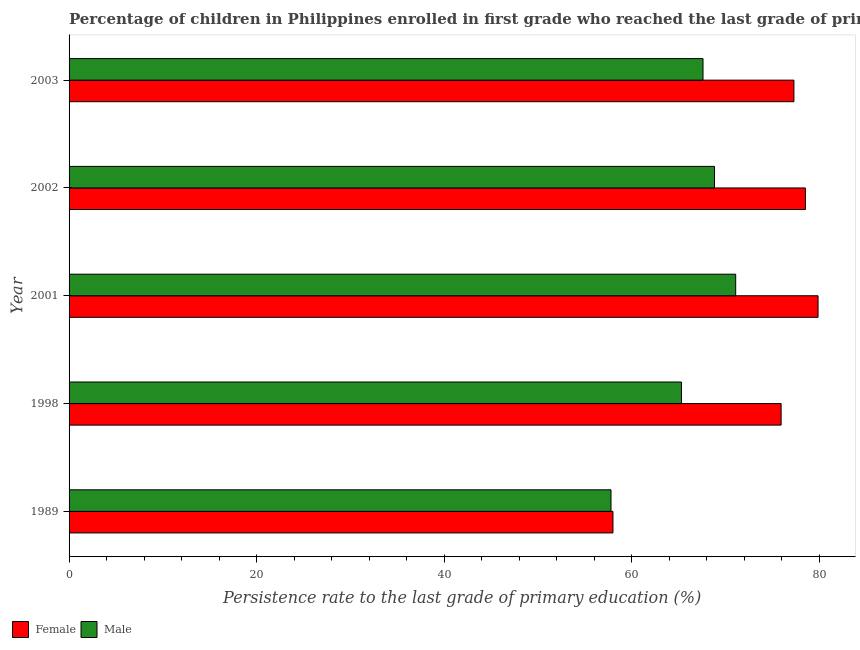How many groups of bars are there?
Your answer should be very brief. 5. Are the number of bars per tick equal to the number of legend labels?
Offer a very short reply. Yes. How many bars are there on the 2nd tick from the top?
Provide a succinct answer. 2. How many bars are there on the 1st tick from the bottom?
Offer a very short reply. 2. What is the label of the 5th group of bars from the top?
Your answer should be compact. 1989. What is the persistence rate of male students in 2001?
Offer a terse response. 71.07. Across all years, what is the maximum persistence rate of female students?
Your answer should be very brief. 79.85. Across all years, what is the minimum persistence rate of male students?
Your answer should be very brief. 57.78. In which year was the persistence rate of female students maximum?
Keep it short and to the point. 2001. What is the total persistence rate of female students in the graph?
Provide a short and direct response. 369.52. What is the difference between the persistence rate of female students in 1998 and that in 2003?
Keep it short and to the point. -1.36. What is the difference between the persistence rate of male students in 1989 and the persistence rate of female students in 2001?
Offer a terse response. -22.07. What is the average persistence rate of female students per year?
Offer a terse response. 73.9. In the year 1989, what is the difference between the persistence rate of male students and persistence rate of female students?
Provide a short and direct response. -0.21. What is the ratio of the persistence rate of male students in 1989 to that in 2001?
Give a very brief answer. 0.81. Is the difference between the persistence rate of male students in 1998 and 2002 greater than the difference between the persistence rate of female students in 1998 and 2002?
Keep it short and to the point. No. What is the difference between the highest and the second highest persistence rate of female students?
Ensure brevity in your answer.  1.35. What is the difference between the highest and the lowest persistence rate of female students?
Your answer should be compact. 21.86. In how many years, is the persistence rate of female students greater than the average persistence rate of female students taken over all years?
Your response must be concise. 4. What does the 2nd bar from the bottom in 2003 represents?
Keep it short and to the point. Male. Are the values on the major ticks of X-axis written in scientific E-notation?
Your response must be concise. No. Does the graph contain any zero values?
Provide a short and direct response. No. How are the legend labels stacked?
Ensure brevity in your answer.  Horizontal. What is the title of the graph?
Give a very brief answer. Percentage of children in Philippines enrolled in first grade who reached the last grade of primary education. Does "By country of asylum" appear as one of the legend labels in the graph?
Give a very brief answer. No. What is the label or title of the X-axis?
Offer a very short reply. Persistence rate to the last grade of primary education (%). What is the Persistence rate to the last grade of primary education (%) in Female in 1989?
Offer a very short reply. 57.98. What is the Persistence rate to the last grade of primary education (%) in Male in 1989?
Give a very brief answer. 57.78. What is the Persistence rate to the last grade of primary education (%) in Female in 1998?
Provide a succinct answer. 75.91. What is the Persistence rate to the last grade of primary education (%) in Male in 1998?
Provide a short and direct response. 65.29. What is the Persistence rate to the last grade of primary education (%) of Female in 2001?
Your answer should be compact. 79.85. What is the Persistence rate to the last grade of primary education (%) in Male in 2001?
Ensure brevity in your answer.  71.07. What is the Persistence rate to the last grade of primary education (%) of Female in 2002?
Keep it short and to the point. 78.5. What is the Persistence rate to the last grade of primary education (%) of Male in 2002?
Give a very brief answer. 68.81. What is the Persistence rate to the last grade of primary education (%) of Female in 2003?
Give a very brief answer. 77.28. What is the Persistence rate to the last grade of primary education (%) in Male in 2003?
Your answer should be very brief. 67.58. Across all years, what is the maximum Persistence rate to the last grade of primary education (%) of Female?
Your response must be concise. 79.85. Across all years, what is the maximum Persistence rate to the last grade of primary education (%) of Male?
Make the answer very short. 71.07. Across all years, what is the minimum Persistence rate to the last grade of primary education (%) in Female?
Your answer should be compact. 57.98. Across all years, what is the minimum Persistence rate to the last grade of primary education (%) of Male?
Provide a short and direct response. 57.78. What is the total Persistence rate to the last grade of primary education (%) of Female in the graph?
Your answer should be compact. 369.52. What is the total Persistence rate to the last grade of primary education (%) of Male in the graph?
Ensure brevity in your answer.  330.52. What is the difference between the Persistence rate to the last grade of primary education (%) in Female in 1989 and that in 1998?
Your answer should be very brief. -17.93. What is the difference between the Persistence rate to the last grade of primary education (%) in Male in 1989 and that in 1998?
Give a very brief answer. -7.51. What is the difference between the Persistence rate to the last grade of primary education (%) of Female in 1989 and that in 2001?
Keep it short and to the point. -21.86. What is the difference between the Persistence rate to the last grade of primary education (%) in Male in 1989 and that in 2001?
Offer a very short reply. -13.29. What is the difference between the Persistence rate to the last grade of primary education (%) of Female in 1989 and that in 2002?
Your answer should be very brief. -20.52. What is the difference between the Persistence rate to the last grade of primary education (%) in Male in 1989 and that in 2002?
Provide a short and direct response. -11.03. What is the difference between the Persistence rate to the last grade of primary education (%) in Female in 1989 and that in 2003?
Give a very brief answer. -19.29. What is the difference between the Persistence rate to the last grade of primary education (%) of Male in 1989 and that in 2003?
Make the answer very short. -9.81. What is the difference between the Persistence rate to the last grade of primary education (%) of Female in 1998 and that in 2001?
Your answer should be very brief. -3.94. What is the difference between the Persistence rate to the last grade of primary education (%) of Male in 1998 and that in 2001?
Your answer should be very brief. -5.78. What is the difference between the Persistence rate to the last grade of primary education (%) in Female in 1998 and that in 2002?
Your response must be concise. -2.59. What is the difference between the Persistence rate to the last grade of primary education (%) in Male in 1998 and that in 2002?
Your response must be concise. -3.52. What is the difference between the Persistence rate to the last grade of primary education (%) in Female in 1998 and that in 2003?
Your answer should be very brief. -1.37. What is the difference between the Persistence rate to the last grade of primary education (%) in Male in 1998 and that in 2003?
Your answer should be very brief. -2.3. What is the difference between the Persistence rate to the last grade of primary education (%) of Female in 2001 and that in 2002?
Your answer should be compact. 1.35. What is the difference between the Persistence rate to the last grade of primary education (%) in Male in 2001 and that in 2002?
Offer a very short reply. 2.26. What is the difference between the Persistence rate to the last grade of primary education (%) of Female in 2001 and that in 2003?
Keep it short and to the point. 2.57. What is the difference between the Persistence rate to the last grade of primary education (%) in Male in 2001 and that in 2003?
Make the answer very short. 3.48. What is the difference between the Persistence rate to the last grade of primary education (%) of Female in 2002 and that in 2003?
Ensure brevity in your answer.  1.23. What is the difference between the Persistence rate to the last grade of primary education (%) of Male in 2002 and that in 2003?
Make the answer very short. 1.22. What is the difference between the Persistence rate to the last grade of primary education (%) of Female in 1989 and the Persistence rate to the last grade of primary education (%) of Male in 1998?
Ensure brevity in your answer.  -7.3. What is the difference between the Persistence rate to the last grade of primary education (%) in Female in 1989 and the Persistence rate to the last grade of primary education (%) in Male in 2001?
Provide a short and direct response. -13.08. What is the difference between the Persistence rate to the last grade of primary education (%) in Female in 1989 and the Persistence rate to the last grade of primary education (%) in Male in 2002?
Ensure brevity in your answer.  -10.82. What is the difference between the Persistence rate to the last grade of primary education (%) of Female in 1989 and the Persistence rate to the last grade of primary education (%) of Male in 2003?
Ensure brevity in your answer.  -9.6. What is the difference between the Persistence rate to the last grade of primary education (%) of Female in 1998 and the Persistence rate to the last grade of primary education (%) of Male in 2001?
Offer a very short reply. 4.84. What is the difference between the Persistence rate to the last grade of primary education (%) of Female in 1998 and the Persistence rate to the last grade of primary education (%) of Male in 2002?
Keep it short and to the point. 7.1. What is the difference between the Persistence rate to the last grade of primary education (%) of Female in 1998 and the Persistence rate to the last grade of primary education (%) of Male in 2003?
Ensure brevity in your answer.  8.33. What is the difference between the Persistence rate to the last grade of primary education (%) in Female in 2001 and the Persistence rate to the last grade of primary education (%) in Male in 2002?
Offer a very short reply. 11.04. What is the difference between the Persistence rate to the last grade of primary education (%) in Female in 2001 and the Persistence rate to the last grade of primary education (%) in Male in 2003?
Keep it short and to the point. 12.26. What is the difference between the Persistence rate to the last grade of primary education (%) of Female in 2002 and the Persistence rate to the last grade of primary education (%) of Male in 2003?
Provide a succinct answer. 10.92. What is the average Persistence rate to the last grade of primary education (%) in Female per year?
Offer a very short reply. 73.9. What is the average Persistence rate to the last grade of primary education (%) in Male per year?
Offer a terse response. 66.1. In the year 1989, what is the difference between the Persistence rate to the last grade of primary education (%) of Female and Persistence rate to the last grade of primary education (%) of Male?
Your answer should be compact. 0.21. In the year 1998, what is the difference between the Persistence rate to the last grade of primary education (%) of Female and Persistence rate to the last grade of primary education (%) of Male?
Keep it short and to the point. 10.62. In the year 2001, what is the difference between the Persistence rate to the last grade of primary education (%) of Female and Persistence rate to the last grade of primary education (%) of Male?
Make the answer very short. 8.78. In the year 2002, what is the difference between the Persistence rate to the last grade of primary education (%) of Female and Persistence rate to the last grade of primary education (%) of Male?
Ensure brevity in your answer.  9.69. In the year 2003, what is the difference between the Persistence rate to the last grade of primary education (%) of Female and Persistence rate to the last grade of primary education (%) of Male?
Provide a succinct answer. 9.69. What is the ratio of the Persistence rate to the last grade of primary education (%) of Female in 1989 to that in 1998?
Make the answer very short. 0.76. What is the ratio of the Persistence rate to the last grade of primary education (%) in Male in 1989 to that in 1998?
Offer a very short reply. 0.88. What is the ratio of the Persistence rate to the last grade of primary education (%) of Female in 1989 to that in 2001?
Ensure brevity in your answer.  0.73. What is the ratio of the Persistence rate to the last grade of primary education (%) of Male in 1989 to that in 2001?
Provide a short and direct response. 0.81. What is the ratio of the Persistence rate to the last grade of primary education (%) of Female in 1989 to that in 2002?
Your answer should be compact. 0.74. What is the ratio of the Persistence rate to the last grade of primary education (%) of Male in 1989 to that in 2002?
Ensure brevity in your answer.  0.84. What is the ratio of the Persistence rate to the last grade of primary education (%) in Female in 1989 to that in 2003?
Your answer should be very brief. 0.75. What is the ratio of the Persistence rate to the last grade of primary education (%) of Male in 1989 to that in 2003?
Your answer should be compact. 0.85. What is the ratio of the Persistence rate to the last grade of primary education (%) in Female in 1998 to that in 2001?
Your answer should be compact. 0.95. What is the ratio of the Persistence rate to the last grade of primary education (%) in Male in 1998 to that in 2001?
Offer a very short reply. 0.92. What is the ratio of the Persistence rate to the last grade of primary education (%) in Female in 1998 to that in 2002?
Your response must be concise. 0.97. What is the ratio of the Persistence rate to the last grade of primary education (%) in Male in 1998 to that in 2002?
Give a very brief answer. 0.95. What is the ratio of the Persistence rate to the last grade of primary education (%) in Female in 1998 to that in 2003?
Offer a terse response. 0.98. What is the ratio of the Persistence rate to the last grade of primary education (%) in Female in 2001 to that in 2002?
Offer a terse response. 1.02. What is the ratio of the Persistence rate to the last grade of primary education (%) in Male in 2001 to that in 2002?
Offer a terse response. 1.03. What is the ratio of the Persistence rate to the last grade of primary education (%) in Male in 2001 to that in 2003?
Give a very brief answer. 1.05. What is the ratio of the Persistence rate to the last grade of primary education (%) in Female in 2002 to that in 2003?
Your answer should be compact. 1.02. What is the ratio of the Persistence rate to the last grade of primary education (%) in Male in 2002 to that in 2003?
Make the answer very short. 1.02. What is the difference between the highest and the second highest Persistence rate to the last grade of primary education (%) in Female?
Offer a terse response. 1.35. What is the difference between the highest and the second highest Persistence rate to the last grade of primary education (%) of Male?
Ensure brevity in your answer.  2.26. What is the difference between the highest and the lowest Persistence rate to the last grade of primary education (%) in Female?
Your answer should be compact. 21.86. What is the difference between the highest and the lowest Persistence rate to the last grade of primary education (%) of Male?
Offer a terse response. 13.29. 